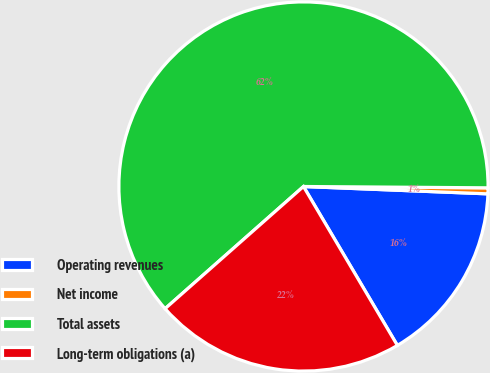<chart> <loc_0><loc_0><loc_500><loc_500><pie_chart><fcel>Operating revenues<fcel>Net income<fcel>Total assets<fcel>Long-term obligations (a)<nl><fcel>15.87%<fcel>0.52%<fcel>61.62%<fcel>21.98%<nl></chart> 